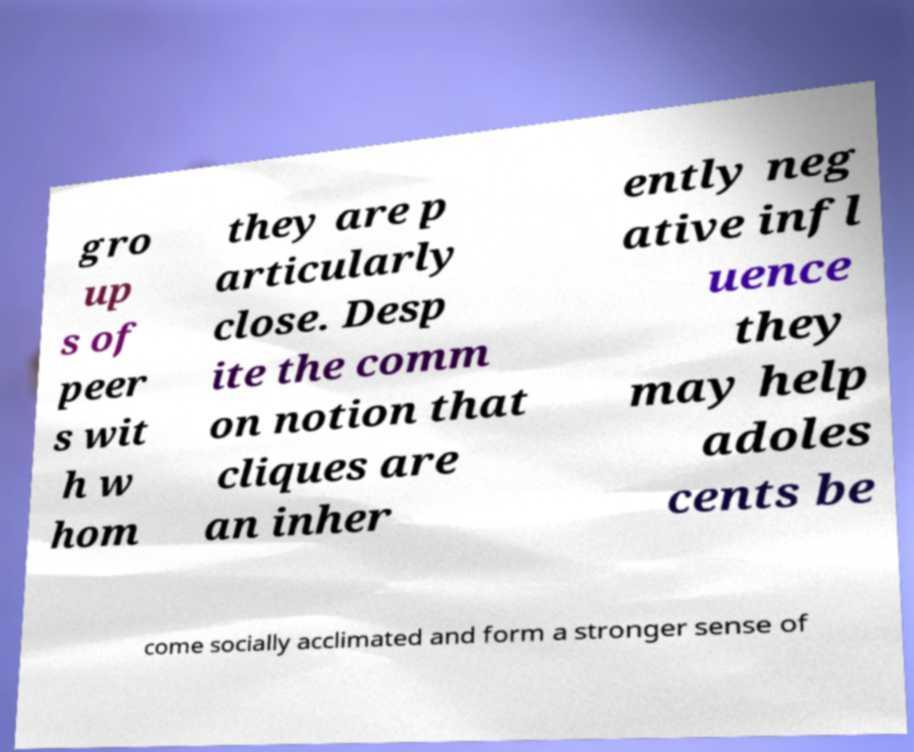Please identify and transcribe the text found in this image. gro up s of peer s wit h w hom they are p articularly close. Desp ite the comm on notion that cliques are an inher ently neg ative infl uence they may help adoles cents be come socially acclimated and form a stronger sense of 